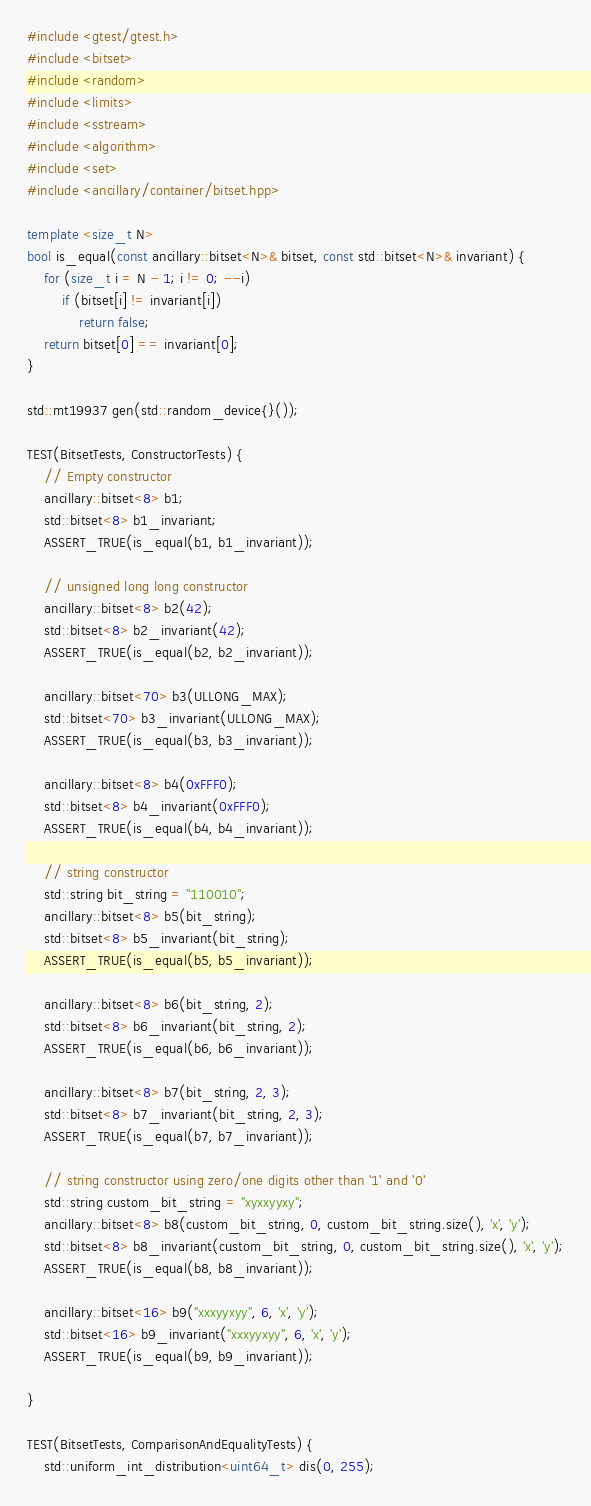<code> <loc_0><loc_0><loc_500><loc_500><_C++_>#include <gtest/gtest.h>
#include <bitset>
#include <random>
#include <limits>
#include <sstream>
#include <algorithm>
#include <set>
#include <ancillary/container/bitset.hpp>

template <size_t N>
bool is_equal(const ancillary::bitset<N>& bitset, const std::bitset<N>& invariant) {
	for (size_t i = N - 1; i != 0; --i)
		if (bitset[i] != invariant[i])
			return false;
	return bitset[0] == invariant[0];
}

std::mt19937 gen(std::random_device{}());

TEST(BitsetTests, ConstructorTests) {
	// Empty constructor
	ancillary::bitset<8> b1;
	std::bitset<8> b1_invariant;
	ASSERT_TRUE(is_equal(b1, b1_invariant));

	// unsigned long long constructor
	ancillary::bitset<8> b2(42);
	std::bitset<8> b2_invariant(42);
	ASSERT_TRUE(is_equal(b2, b2_invariant));
	
	ancillary::bitset<70> b3(ULLONG_MAX);
	std::bitset<70> b3_invariant(ULLONG_MAX);
	ASSERT_TRUE(is_equal(b3, b3_invariant));
	
	ancillary::bitset<8> b4(0xFFF0);
	std::bitset<8> b4_invariant(0xFFF0);
	ASSERT_TRUE(is_equal(b4, b4_invariant));

	// string constructor
	std::string bit_string = "110010";
	ancillary::bitset<8> b5(bit_string);
	std::bitset<8> b5_invariant(bit_string);
	ASSERT_TRUE(is_equal(b5, b5_invariant));
	
	ancillary::bitset<8> b6(bit_string, 2);
	std::bitset<8> b6_invariant(bit_string, 2);
	ASSERT_TRUE(is_equal(b6, b6_invariant));
	
	ancillary::bitset<8> b7(bit_string, 2, 3);
	std::bitset<8> b7_invariant(bit_string, 2, 3);
	ASSERT_TRUE(is_equal(b7, b7_invariant));
	
	// string constructor using zero/one digits other than '1' and '0'
	std::string custom_bit_string = "xyxxyyxy";
	ancillary::bitset<8> b8(custom_bit_string, 0, custom_bit_string.size(), 'x', 'y');
	std::bitset<8> b8_invariant(custom_bit_string, 0, custom_bit_string.size(), 'x', 'y');
	ASSERT_TRUE(is_equal(b8, b8_invariant));
	
	ancillary::bitset<16> b9("xxxyyxyy", 6, 'x', 'y');
	std::bitset<16> b9_invariant("xxxyyxyy", 6, 'x', 'y');
	ASSERT_TRUE(is_equal(b9, b9_invariant));

}

TEST(BitsetTests, ComparisonAndEqualityTests) {
	std::uniform_int_distribution<uint64_t> dis(0, 255);</code> 